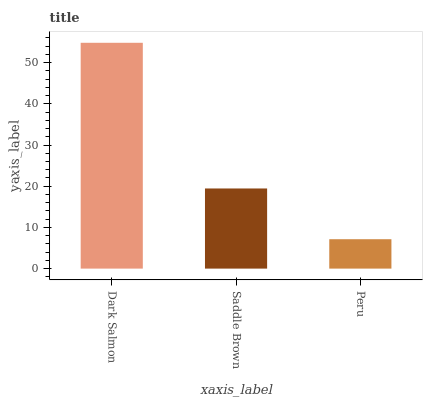Is Peru the minimum?
Answer yes or no. Yes. Is Dark Salmon the maximum?
Answer yes or no. Yes. Is Saddle Brown the minimum?
Answer yes or no. No. Is Saddle Brown the maximum?
Answer yes or no. No. Is Dark Salmon greater than Saddle Brown?
Answer yes or no. Yes. Is Saddle Brown less than Dark Salmon?
Answer yes or no. Yes. Is Saddle Brown greater than Dark Salmon?
Answer yes or no. No. Is Dark Salmon less than Saddle Brown?
Answer yes or no. No. Is Saddle Brown the high median?
Answer yes or no. Yes. Is Saddle Brown the low median?
Answer yes or no. Yes. Is Dark Salmon the high median?
Answer yes or no. No. Is Dark Salmon the low median?
Answer yes or no. No. 